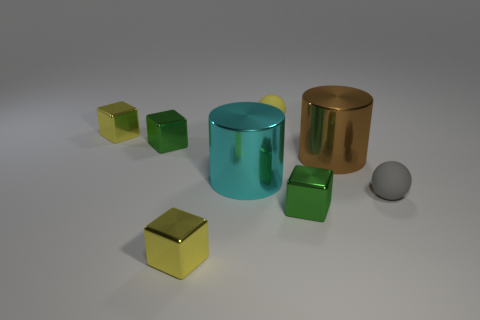There is a small gray matte object that is on the right side of the cyan metal thing; is its shape the same as the yellow matte object?
Your response must be concise. Yes. There is a green thing that is behind the small metallic object that is to the right of the cylinder in front of the big brown shiny cylinder; what shape is it?
Your answer should be compact. Cube. What size is the brown metal object?
Provide a succinct answer. Large. There is a small object that is the same material as the yellow ball; what color is it?
Give a very brief answer. Gray. What number of small blocks are the same material as the big cyan cylinder?
Provide a short and direct response. 4. What color is the large metal cylinder that is left of the tiny sphere behind the tiny gray ball?
Provide a succinct answer. Cyan. What is the color of the other shiny cylinder that is the same size as the brown cylinder?
Make the answer very short. Cyan. Are there any brown objects of the same shape as the large cyan thing?
Keep it short and to the point. Yes. The brown thing is what shape?
Keep it short and to the point. Cylinder. Is the number of green objects that are left of the yellow rubber object greater than the number of yellow spheres right of the gray matte ball?
Give a very brief answer. Yes. 